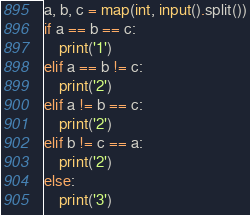Convert code to text. <code><loc_0><loc_0><loc_500><loc_500><_Python_>a, b, c = map(int, input().split())
if a == b == c:
    print('1')
elif a == b != c:
    print('2')
elif a != b == c:
    print('2')
elif b != c == a:
    print('2')
else:
    print('3')</code> 